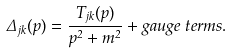<formula> <loc_0><loc_0><loc_500><loc_500>\Delta _ { j k } ( p ) = \frac { T _ { j k } ( p ) } { p ^ { 2 } + m ^ { 2 } } + g a u g e \, t e r m s .</formula> 